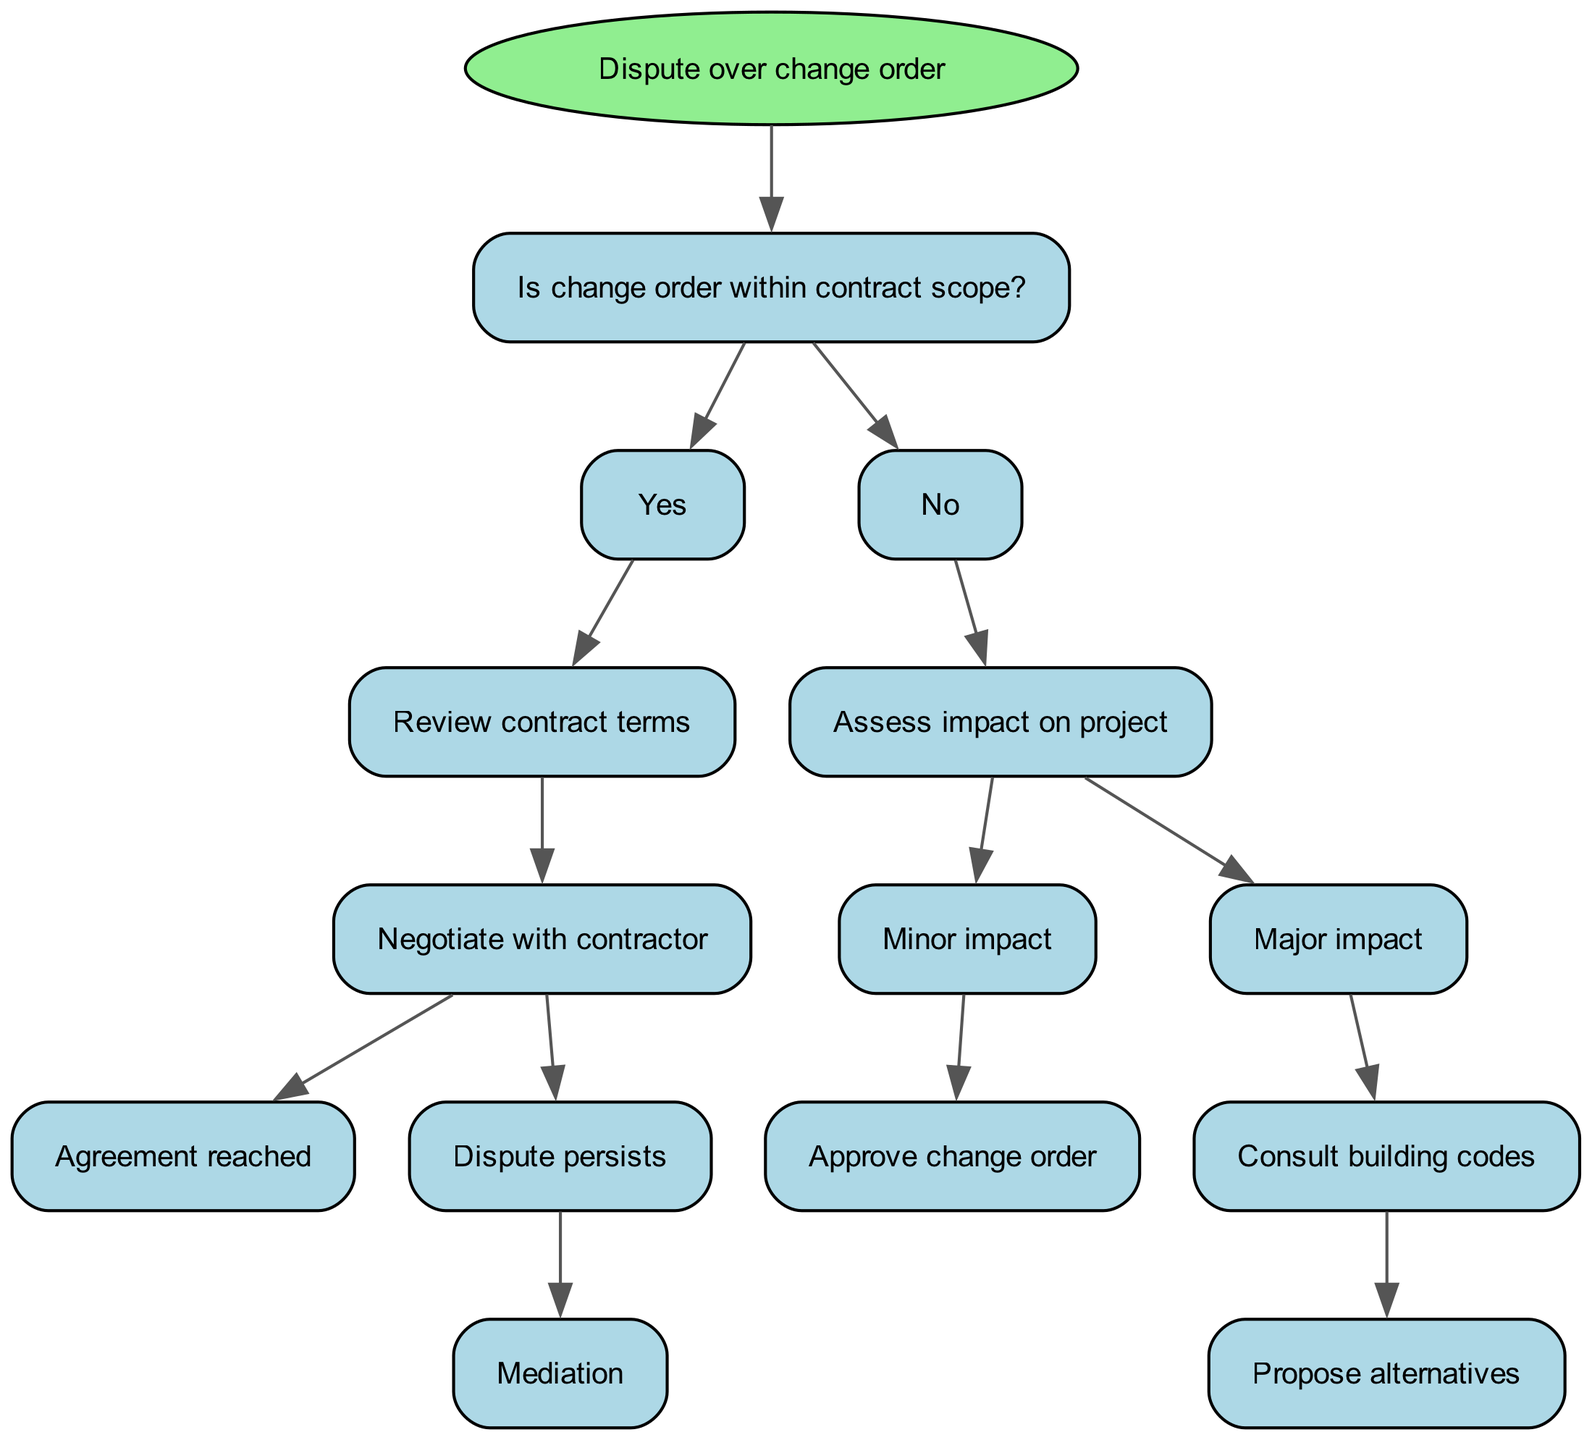What is the root of the decision tree? The root of the decision tree is described in the initial section of the diagram, which states "Dispute over change order."
Answer: Dispute over change order How many children does the node "Is change order within contract scope?" have? By looking at the node "Is change order within contract scope?", it can be seen that it has two children: "Yes" and "No."
Answer: 2 What action is taken if the change order is within contract scope and an agreement is reached? If an agreement is reached after negotiating with the contractor, the corresponding action from the diagram is represented at that end node.
Answer: Agreement reached What is the next step if the change order is not within the contract scope and it has a major impact? Following the flow, if the change order is assessed as having a major impact, the next step is consulting building codes.
Answer: Consult building codes What happens if the change order is within the contract scope but the dispute persists? The diagram indicates that if a dispute persists after negotiations for a change order within the contract scope, the next action is mediation.
Answer: Mediation What should be assessed when a change order is not within the contract scope? When a change order is not within the contract scope, the first step is to assess the impact on the project as indicated by the branches stemming from the "No".
Answer: Assess impact on project What options are available if the change order results in a minor impact? According to the diagram, if there is a minor impact from the change order, the option available is to approve the change order.
Answer: Approve change order What is the terminal action if a change order has a major impact? If the change order has a major impact, the terminal action involves proposing alternatives after consulting building codes.
Answer: Propose alternatives 